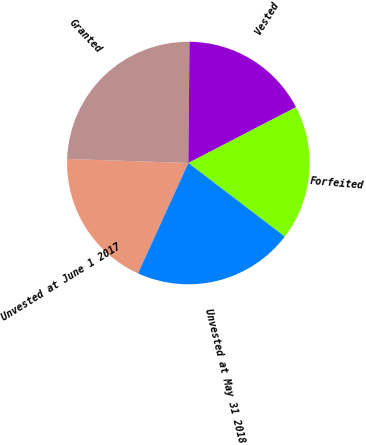<chart> <loc_0><loc_0><loc_500><loc_500><pie_chart><fcel>Unvested at June 1 2017<fcel>Granted<fcel>Vested<fcel>Forfeited<fcel>Unvested at May 31 2018<nl><fcel>18.72%<fcel>24.62%<fcel>17.24%<fcel>17.98%<fcel>21.44%<nl></chart> 